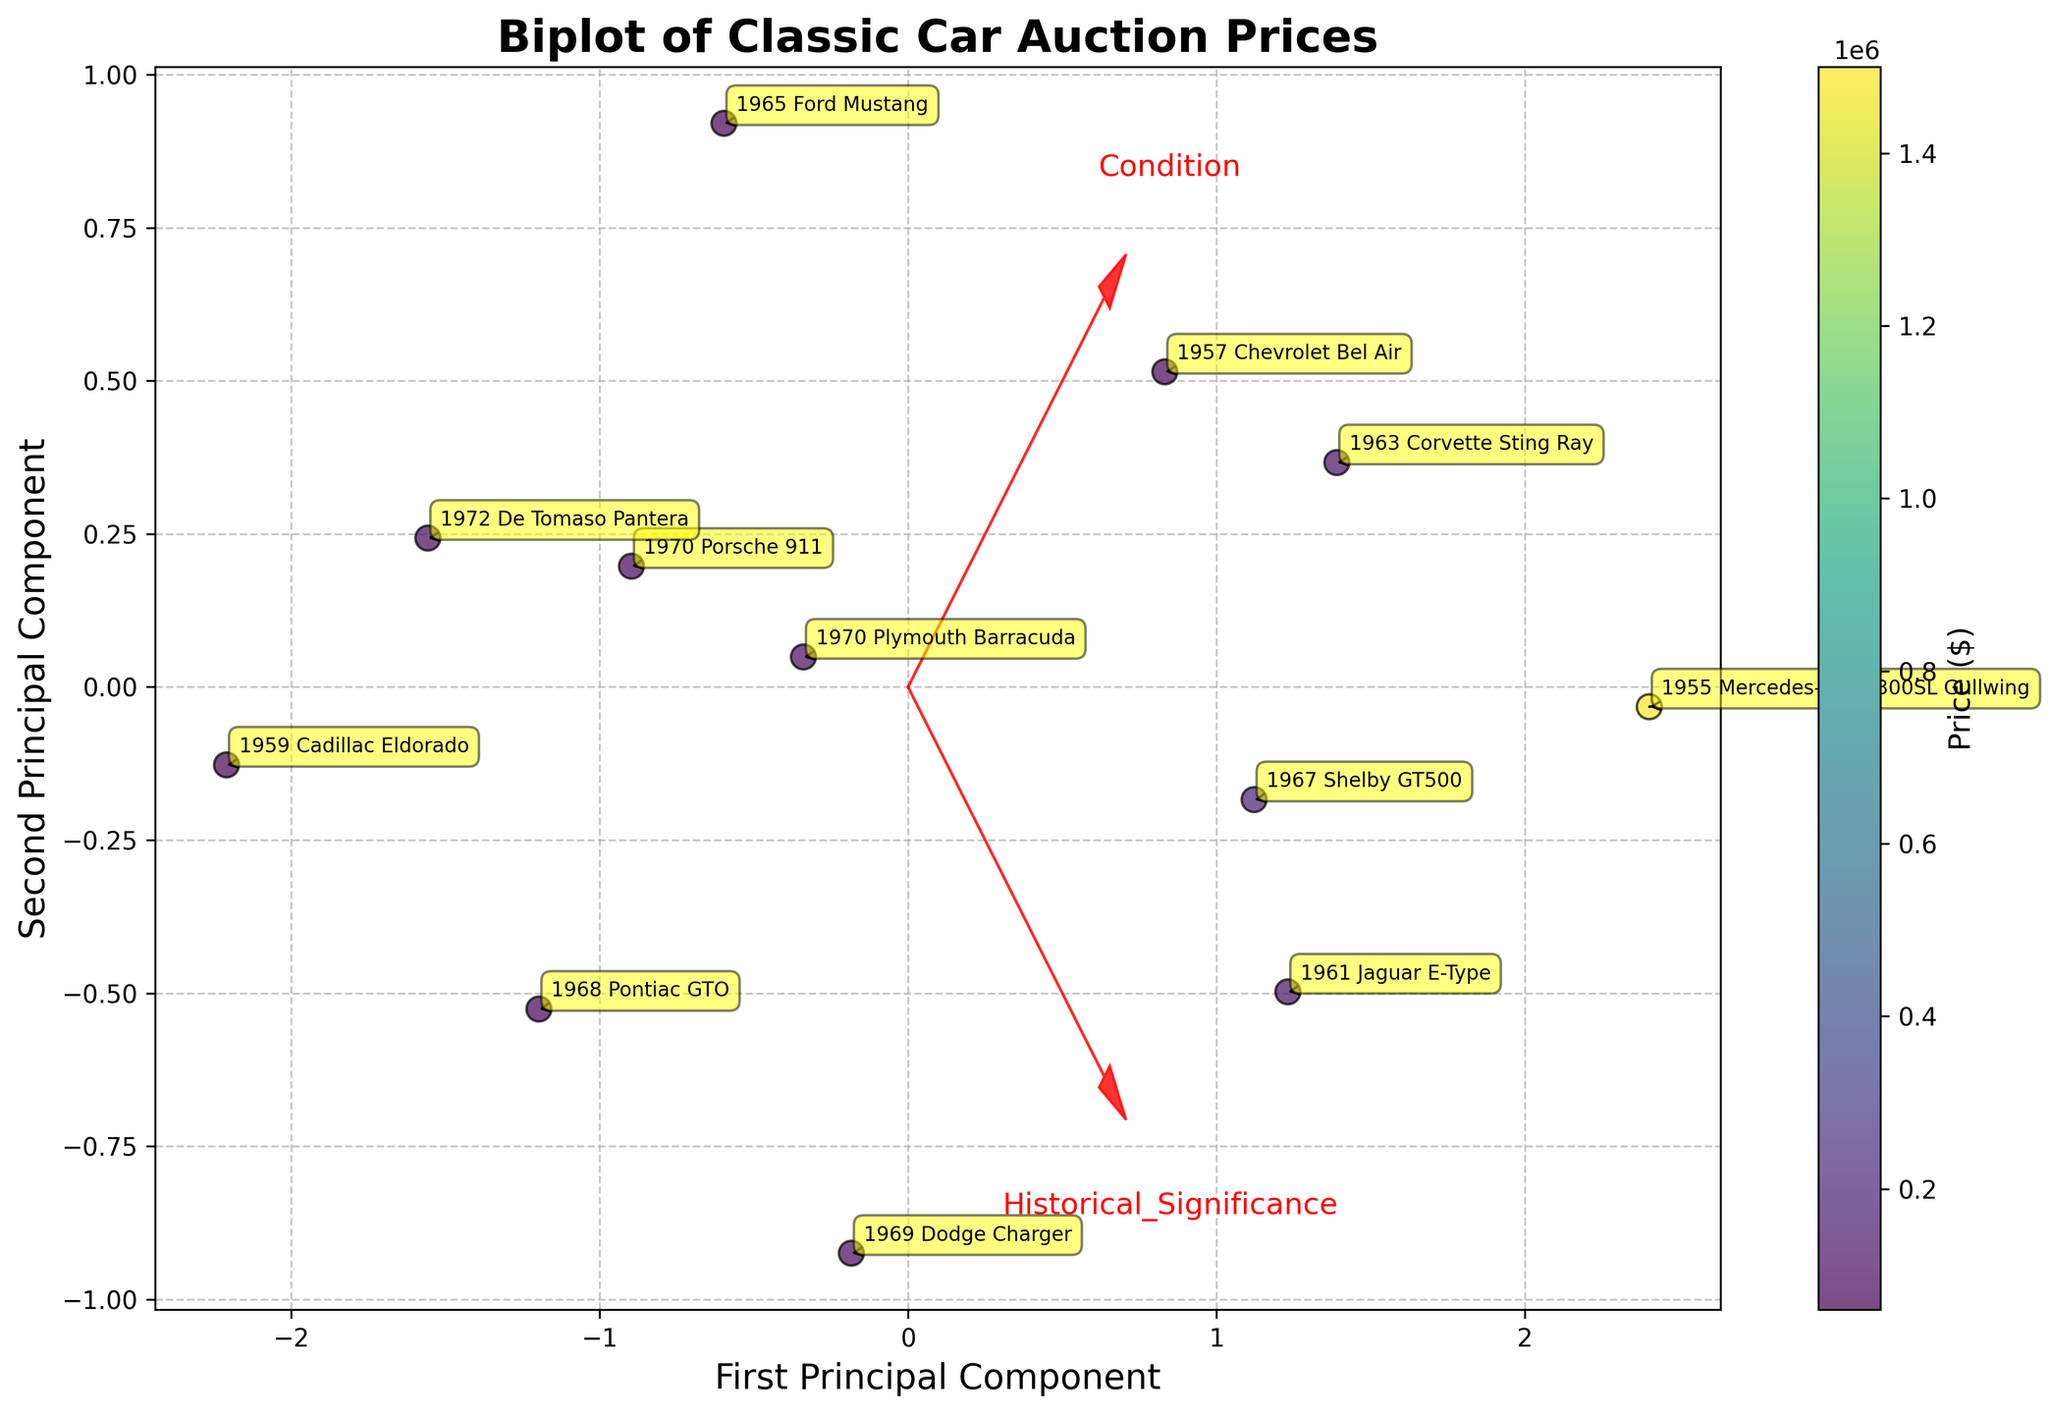What is the title of the plot? The title is located at the top of the figure, it summarizes what the plot is about. It reads "Biplot of Classic Car Auction Prices."
Answer: Biplot of Classic Car Auction Prices What does the color of each data point represent? The color of each data point, indicated by the color gradient and the colorbar on the side, represents the price of the car at auction.
Answer: Price How many principal components are displayed on the axes? The labels on the axes specify the principal components. Both the x-axis and y-axis are labeled as principal components, specifically the first and second principal components.
Answer: Two Which car has the highest auction price and where is it located on the plot? The Cadillac 1955 Mercedes-Benz 300SL Gullwing, annotated on the plot and likely farthest to an extreme due to its high price, has the highest price. Its position needs to be checked on the plot.
Answer: 1955 Mercedes-Benz 300SL Gullwing What feature vectors are depicted with red arrows? The red arrows represent the direction and contribution of the features—vehicle condition and historical significance—on the principal components. The text labels at the end of the arrows indicate which features they correspond to.
Answer: Condition, Historical_Significance Which car is closest to the first principal component axis? By looking at the plot, the car that is very close to the x-axis (first principal component axis) can be identified directly from its position relative to the axis.
Answer: 1959 Cadillac Eldorado Which car has high historical significance but relatively moderate condition? By identifying the car with a higher position along the Historical_Significance arrow and a moderate position along the Condition direction, such a car can be pinpointed.
Answer: 1969 Dodge Charger How do the positions of 1967 Shelby GT500 and 1961 Jaguar E-Type compare in terms of condition and historical significance? By comparing their positions on the plot relative to the arrows (features), one can see that the Jaguar E-Type is further along both arrows compared to the Shelby GT500, indicating it has higher scores in both condition and historical significance.
Answer: The Jaguar E-Type has higher Condition and Historical Significance than the Shelby GT500 What is the general trend between auction prices and car condition/historical significance? Looking at the plot, by observing how colors (representing prices) are distributed relative to the directions of condition and historical significance arrows, a trend can be deduced.
Answer: Higher condition and historical significance generally correspond to higher prices Which cars are outliers in terms of their auction prices? Outliers can be identified by noting which cars are in color gradients significantly different from others, potentially being much lighter or darker. This includes, for instance, the 1955 Mercedes-Benz 300SL Gullwing which is an extreme in terms of price.
Answer: 1955 Mercedes-Benz 300SL Gullwing 